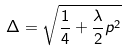<formula> <loc_0><loc_0><loc_500><loc_500>\Delta = \sqrt { \frac { 1 } { 4 } + \frac { \lambda } { 2 } p ^ { 2 } }</formula> 